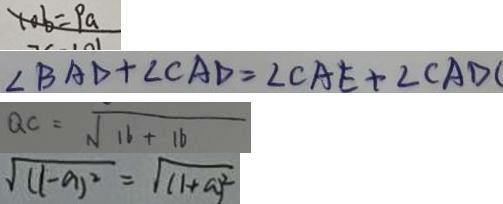Convert formula to latex. <formula><loc_0><loc_0><loc_500><loc_500>1 0 b = P a 
 \angle B A D + \angle C A D = \angle C A E + \angle C A D 
 Q C = \sqrt { 1 6 + 1 6 } 
 \sqrt { ( 1 - a ) ^ { 2 } } = \sqrt { ( 1 + a ) ^ { 2 } }</formula> 